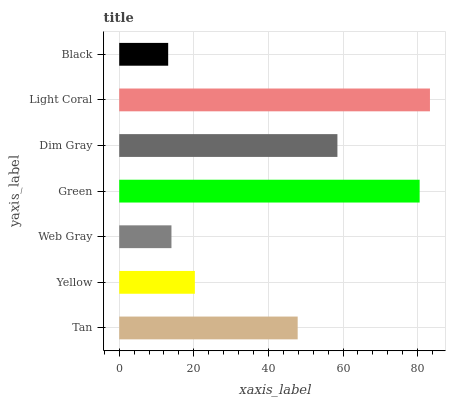Is Black the minimum?
Answer yes or no. Yes. Is Light Coral the maximum?
Answer yes or no. Yes. Is Yellow the minimum?
Answer yes or no. No. Is Yellow the maximum?
Answer yes or no. No. Is Tan greater than Yellow?
Answer yes or no. Yes. Is Yellow less than Tan?
Answer yes or no. Yes. Is Yellow greater than Tan?
Answer yes or no. No. Is Tan less than Yellow?
Answer yes or no. No. Is Tan the high median?
Answer yes or no. Yes. Is Tan the low median?
Answer yes or no. Yes. Is Black the high median?
Answer yes or no. No. Is Light Coral the low median?
Answer yes or no. No. 